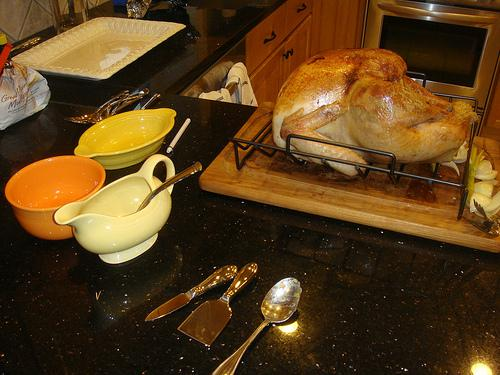Question: what room of the house is this?
Choices:
A. Bedroom.
B. Living room.
C. Dining room.
D. The kitchen.
Answer with the letter. Answer: D Question: what type of meat was cooked?
Choices:
A. Fish.
B. Beef.
C. Poultry.
D. Pork.
Answer with the letter. Answer: C Question: what color is the oven?
Choices:
A. White.
B. Black.
C. Silver.
D. Gray.
Answer with the letter. Answer: C Question: why is the poultry brown?
Choices:
A. Because it is cooked.
B. It is seasoned.
C. It is natural.
D. It is a special brand.
Answer with the letter. Answer: A 